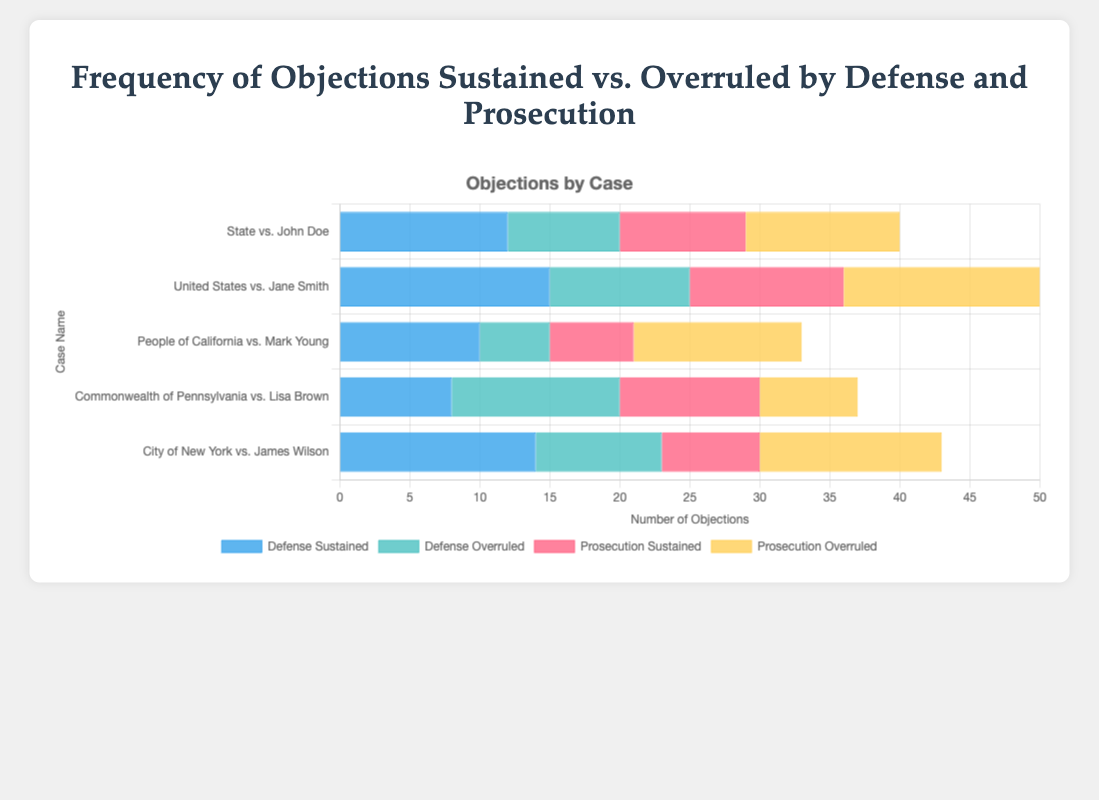What's the total number of objections raised by the defense across all cases? To find the total, sum the sustained and overruled objections by the defense for each case: (12+8)+(15+10)+(10+5)+(8+12)+(14+9) = 38+25+15+20+23 = 121
Answer: 121 In which case did the prosecution have more sustained objections compared to overruled objections? For the prosecution, compare sustained and overruled objections in each case: "State vs. John Doe" (9 vs 11), "United States vs. Jane Smith" (11 vs 14), "People of California vs. Mark Young" (6 vs 12), "Commonwealth of Pennsylvania vs. Lisa Brown" (10 vs 7), "City of New York vs. James Wilson" (7 vs 13). Only "Commonwealth of Pennsylvania vs. Lisa Brown" has more sustained (10) compared to overruled (7).
Answer: Commonwealth of Pennsylvania vs. Lisa Brown How many more sustained objections does the defense have in "United States vs. Jane Smith" compared to "People of California vs. Mark Young"? In "United States vs. Jane Smith", the defense has 15 sustained objections. In "People of California vs. Mark Young", the defense has 10 sustained objections. The difference is 15 - 10 = 5.
Answer: 5 Which case has the highest total number of overruled objections? Calculate the total overruled objections for each case. "State vs. John Doe" (8+11=19), "United States vs. Jane Smith" (10+14=24), "People of California vs. Mark Young" (5+12=17), "Commonwealth of Pennsylvania vs. Lisa Brown" (12+7=19), "City of New York vs. James Wilson" (9+13=22). "United States vs. Jane Smith" and "City of New York vs. James Wilson" both have 24 and 22 overruled objections respectively, making "United States vs. Jane Smith" the highest.
Answer: United States vs. Jane Smith What’s the average number of sustained objections by the defense per case? Sum the sustained objections by the defense and divide by the number of cases. (12+15+10+8+14)/5 = 59/5 = 11.8
Answer: 11.8 Compare the visual heights of bars: In "State vs. John Doe," which is higher, the defense sustained or prosecution sustained bars? Visually compare the heights of the blue bar (defense sustained) and the red bar (prosecution sustained) for "State vs. John Doe." The defense sustained bar appears higher.
Answer: Defense sustained How many fewer sustained objections does the prosecution have compared to the defense in "People of California vs. Mark Young"? The prosecution has 6 sustained objections, while the defense has 10 sustained objections in this case. The difference is 10 - 6 = 4.
Answer: 4 Which case shows the least number of sustained objections by the prosecution? Compare the prosecution sustained objections across cases: 9, 11, 6, 10, 7. "People of California vs. Mark Young" has the smallest number, which is 6.
Answer: People of California vs. Mark Young Is there a case where the number of defense overruled objections equals the number of prosecution sustained objections? Check each case's data: "State vs. John Doe" (8 vs 9), "United States vs. Jane Smith" (10 vs 11), "People of California vs. Mark Young" (5 vs 6), "Commonwealth of Pennsylvania vs. Lisa Brown" (12 vs 10), "City of New York vs. James Wilson" (9 vs 7). No case matches exactly.
Answer: No What's the combined total of sustained objections (defense and prosecution) in "City of New York vs. James Wilson"? Combine the sustained objections for both parties in that case: 14 (defense) + 7 (prosecution) = 21.
Answer: 21 